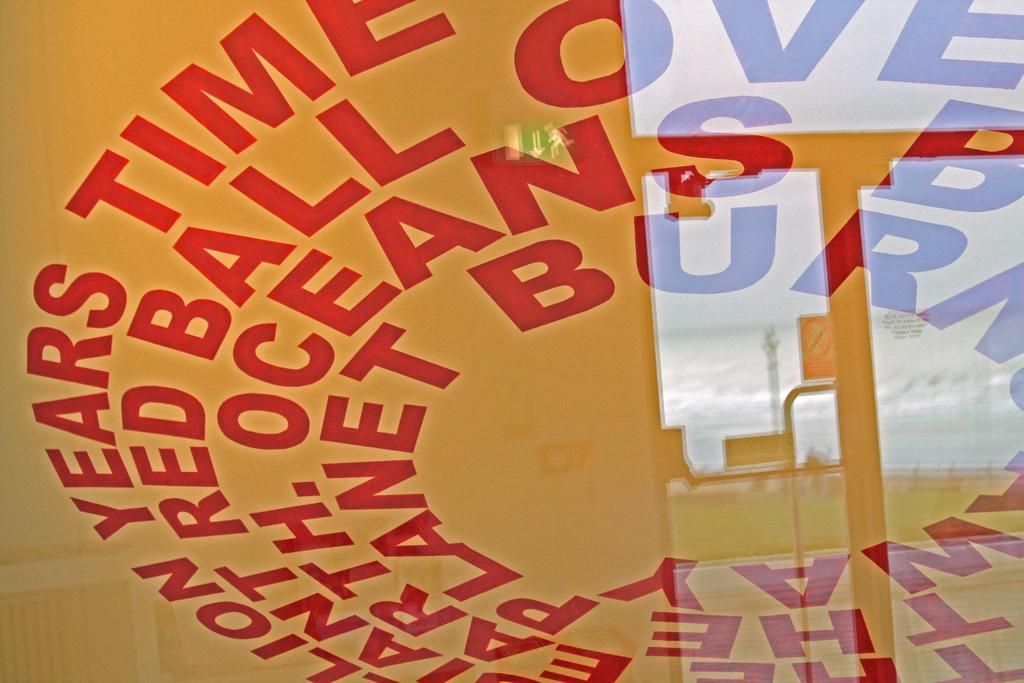<image>
Offer a succinct explanation of the picture presented. The ceiling has the words years, time, red, ball, ocean and planet written in large red letter in a circle. 